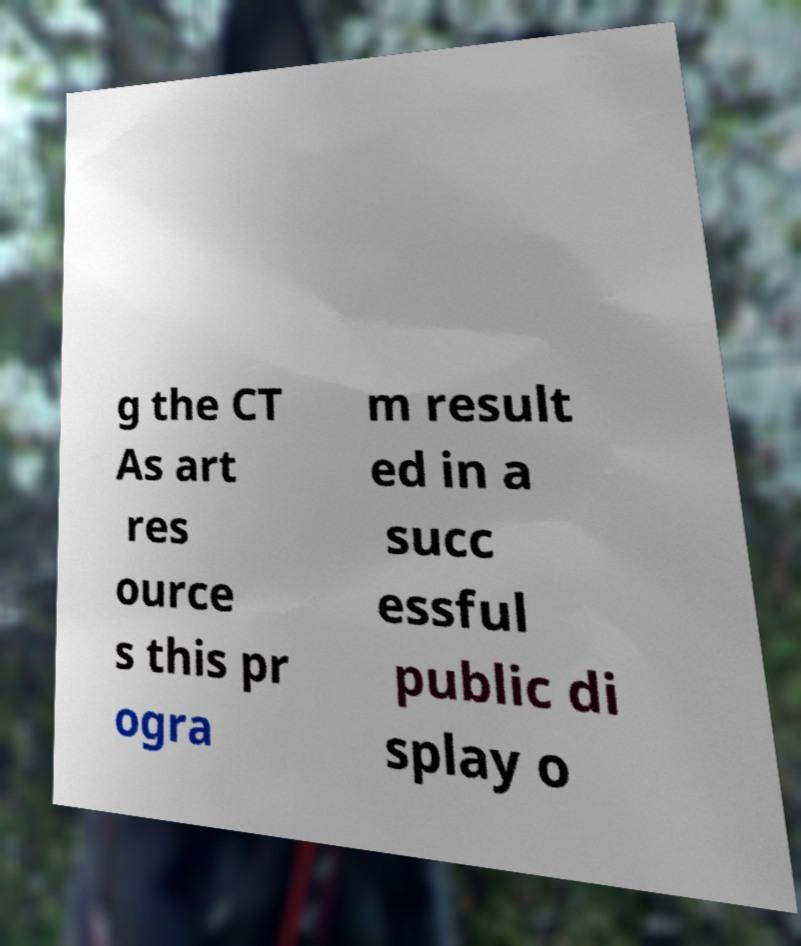There's text embedded in this image that I need extracted. Can you transcribe it verbatim? g the CT As art res ource s this pr ogra m result ed in a succ essful public di splay o 